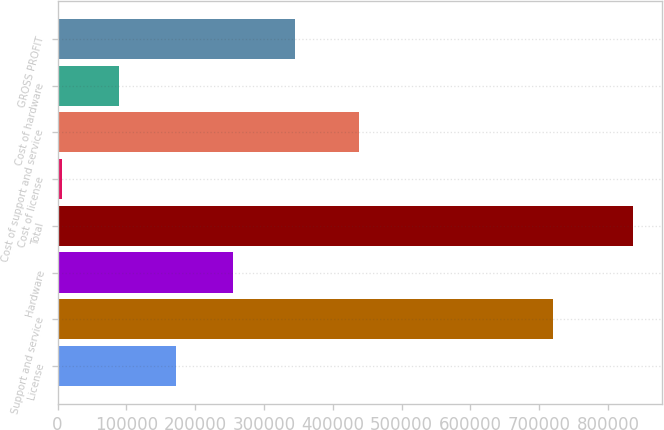Convert chart. <chart><loc_0><loc_0><loc_500><loc_500><bar_chart><fcel>License<fcel>Support and service<fcel>Hardware<fcel>Total<fcel>Cost of license<fcel>Cost of support and service<fcel>Cost of hardware<fcel>GROSS PROFIT<nl><fcel>171979<fcel>720504<fcel>255055<fcel>836586<fcel>5827<fcel>438476<fcel>88902.9<fcel>345120<nl></chart> 